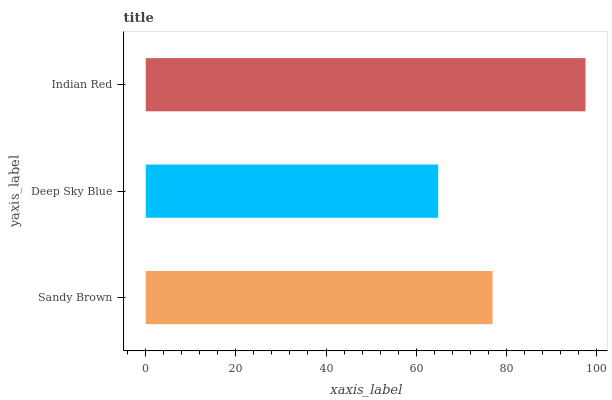Is Deep Sky Blue the minimum?
Answer yes or no. Yes. Is Indian Red the maximum?
Answer yes or no. Yes. Is Indian Red the minimum?
Answer yes or no. No. Is Deep Sky Blue the maximum?
Answer yes or no. No. Is Indian Red greater than Deep Sky Blue?
Answer yes or no. Yes. Is Deep Sky Blue less than Indian Red?
Answer yes or no. Yes. Is Deep Sky Blue greater than Indian Red?
Answer yes or no. No. Is Indian Red less than Deep Sky Blue?
Answer yes or no. No. Is Sandy Brown the high median?
Answer yes or no. Yes. Is Sandy Brown the low median?
Answer yes or no. Yes. Is Deep Sky Blue the high median?
Answer yes or no. No. Is Deep Sky Blue the low median?
Answer yes or no. No. 